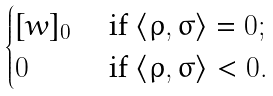<formula> <loc_0><loc_0><loc_500><loc_500>\begin{cases} [ w ] _ { 0 } & \text { if } \langle \varrho , \sigma \rangle = 0 ; \\ 0 & \text { if } \langle \varrho , \sigma \rangle < 0 . \end{cases}</formula> 